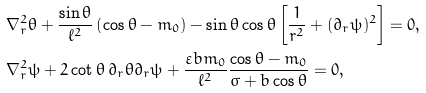<formula> <loc_0><loc_0><loc_500><loc_500>& \nabla _ { r } ^ { 2 } \theta + \frac { \sin \theta } { \ell ^ { 2 } } \left ( \cos \theta - m _ { 0 } \right ) - \sin \theta \cos \theta \left [ \frac { 1 } { r ^ { 2 } } + ( \partial _ { r } \psi ) ^ { 2 } \right ] = 0 , \\ & \nabla _ { r } ^ { 2 } \psi + 2 \cot \theta \, \partial _ { r } \theta \partial _ { r } \psi + \frac { \varepsilon b m _ { 0 } } { \ell ^ { 2 } } \frac { \cos \theta - m _ { 0 } } { \sigma + b \cos \theta } = 0 ,</formula> 